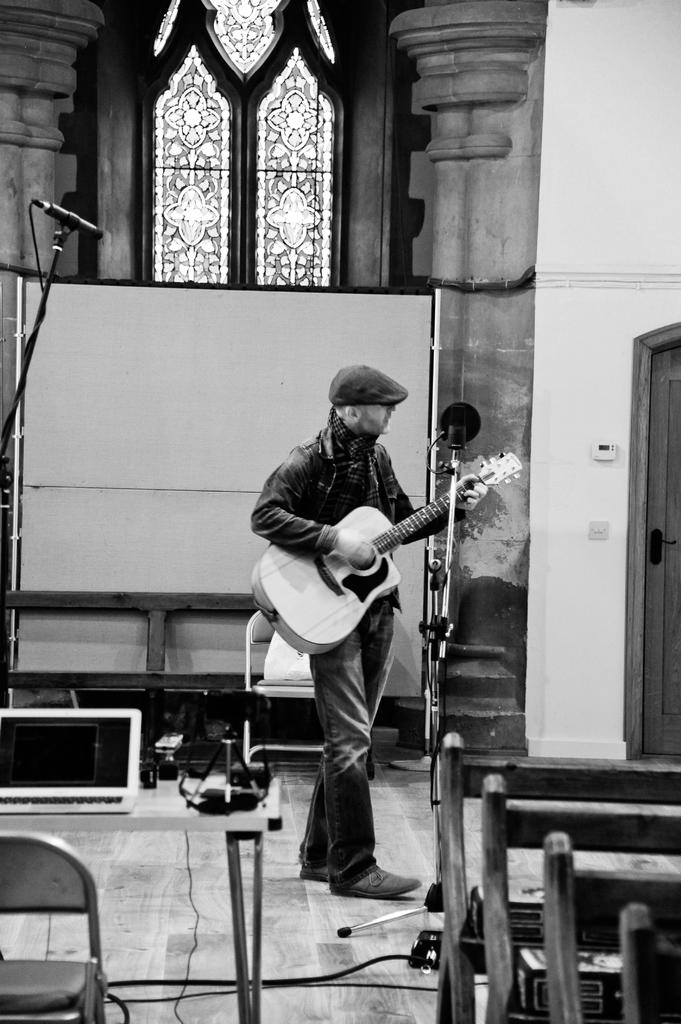What is the color scheme of the image? The image is black and white. Who is present in the image? There is a man in the image. What is the man doing in the image? The man is standing and holding a guitar. What other objects can be seen in the image? There is a microphone and chairs in the image. Is there any indication of the location or setting in the image? Yes, there is a window in the image. What type of book is the man reading in the image? There is no book present in the image; the man is holding a guitar and standing near a microphone and chairs. 